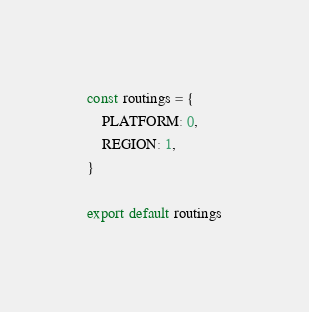Convert code to text. <code><loc_0><loc_0><loc_500><loc_500><_JavaScript_>const routings = {
    PLATFORM: 0,
    REGION: 1,
}

export default routings
</code> 